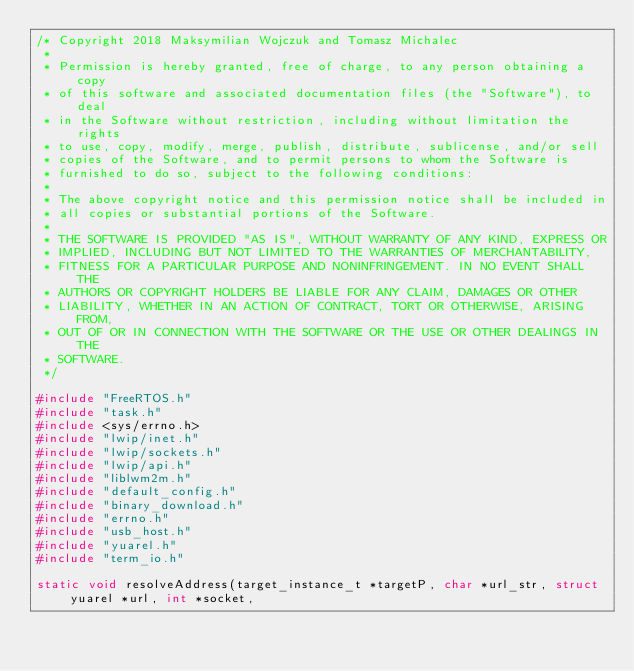<code> <loc_0><loc_0><loc_500><loc_500><_C_>/* Copyright 2018 Maksymilian Wojczuk and Tomasz Michalec
 *
 * Permission is hereby granted, free of charge, to any person obtaining a copy
 * of this software and associated documentation files (the "Software"), to deal
 * in the Software without restriction, including without limitation the rights
 * to use, copy, modify, merge, publish, distribute, sublicense, and/or sell
 * copies of the Software, and to permit persons to whom the Software is
 * furnished to do so, subject to the following conditions:
 *
 * The above copyright notice and this permission notice shall be included in
 * all copies or substantial portions of the Software.
 *
 * THE SOFTWARE IS PROVIDED "AS IS", WITHOUT WARRANTY OF ANY KIND, EXPRESS OR
 * IMPLIED, INCLUDING BUT NOT LIMITED TO THE WARRANTIES OF MERCHANTABILITY,
 * FITNESS FOR A PARTICULAR PURPOSE AND NONINFRINGEMENT. IN NO EVENT SHALL THE
 * AUTHORS OR COPYRIGHT HOLDERS BE LIABLE FOR ANY CLAIM, DAMAGES OR OTHER
 * LIABILITY, WHETHER IN AN ACTION OF CONTRACT, TORT OR OTHERWISE, ARISING FROM,
 * OUT OF OR IN CONNECTION WITH THE SOFTWARE OR THE USE OR OTHER DEALINGS IN THE
 * SOFTWARE.
 */

#include "FreeRTOS.h"
#include "task.h"
#include <sys/errno.h>
#include "lwip/inet.h"
#include "lwip/sockets.h"
#include "lwip/api.h"
#include "liblwm2m.h"
#include "default_config.h"
#include "binary_download.h"
#include "errno.h"
#include "usb_host.h"
#include "yuarel.h"
#include "term_io.h"

static void resolveAddress(target_instance_t *targetP, char *url_str, struct yuarel *url, int *socket,</code> 